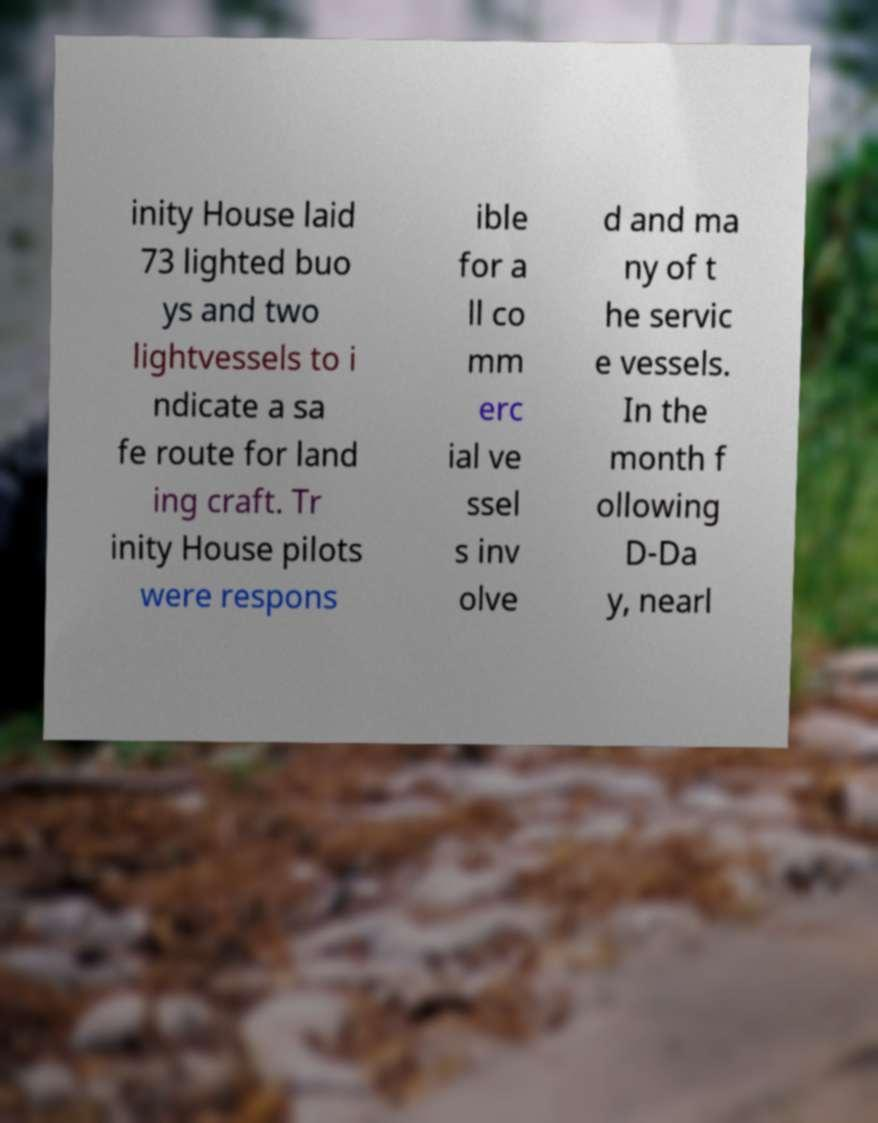Please read and relay the text visible in this image. What does it say? inity House laid 73 lighted buo ys and two lightvessels to i ndicate a sa fe route for land ing craft. Tr inity House pilots were respons ible for a ll co mm erc ial ve ssel s inv olve d and ma ny of t he servic e vessels. In the month f ollowing D-Da y, nearl 